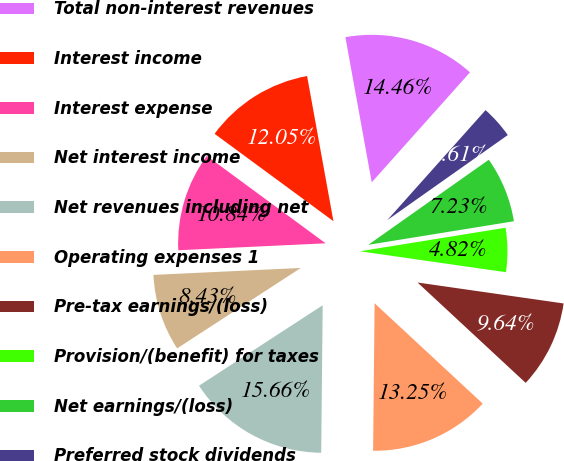<chart> <loc_0><loc_0><loc_500><loc_500><pie_chart><fcel>Total non-interest revenues<fcel>Interest income<fcel>Interest expense<fcel>Net interest income<fcel>Net revenues including net<fcel>Operating expenses 1<fcel>Pre-tax earnings/(loss)<fcel>Provision/(benefit) for taxes<fcel>Net earnings/(loss)<fcel>Preferred stock dividends<nl><fcel>14.46%<fcel>12.05%<fcel>10.84%<fcel>8.43%<fcel>15.66%<fcel>13.25%<fcel>9.64%<fcel>4.82%<fcel>7.23%<fcel>3.61%<nl></chart> 